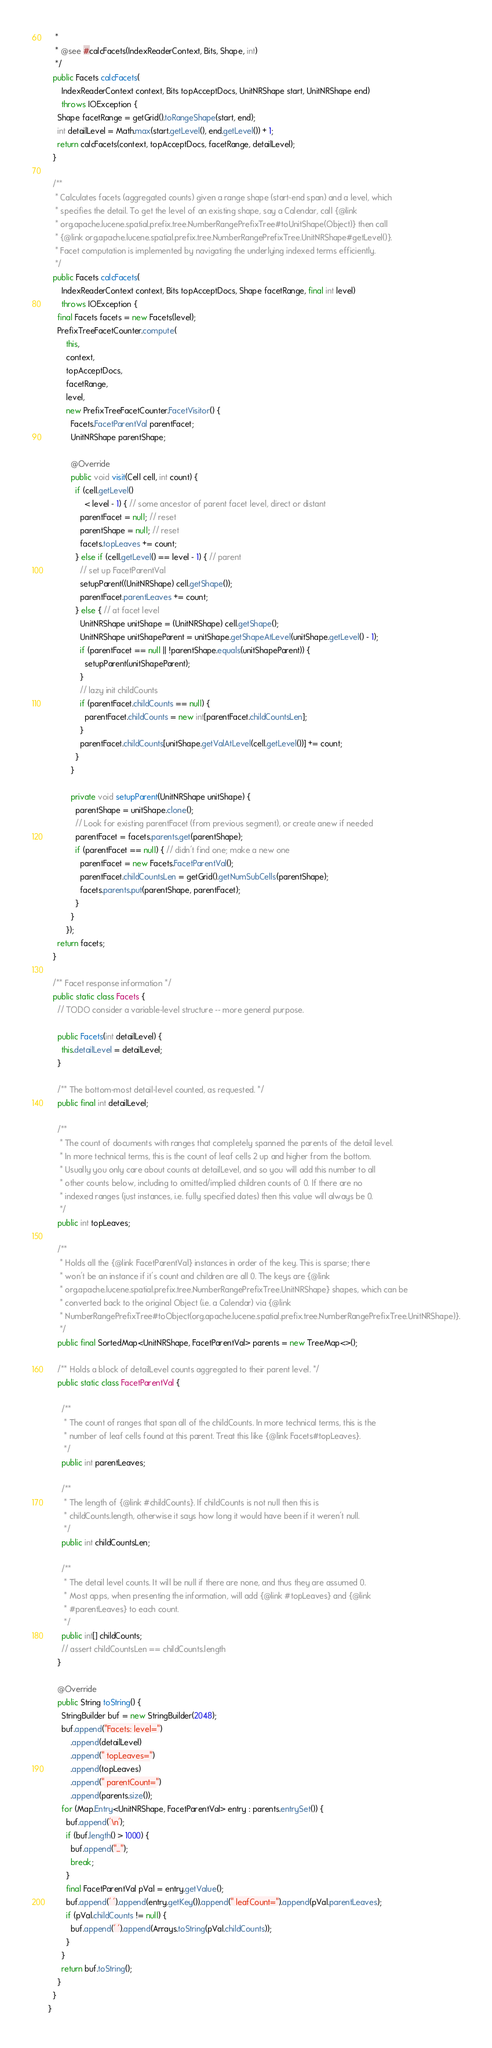Convert code to text. <code><loc_0><loc_0><loc_500><loc_500><_Java_>   *
   * @see #calcFacets(IndexReaderContext, Bits, Shape, int)
   */
  public Facets calcFacets(
      IndexReaderContext context, Bits topAcceptDocs, UnitNRShape start, UnitNRShape end)
      throws IOException {
    Shape facetRange = getGrid().toRangeShape(start, end);
    int detailLevel = Math.max(start.getLevel(), end.getLevel()) + 1;
    return calcFacets(context, topAcceptDocs, facetRange, detailLevel);
  }

  /**
   * Calculates facets (aggregated counts) given a range shape (start-end span) and a level, which
   * specifies the detail. To get the level of an existing shape, say a Calendar, call {@link
   * org.apache.lucene.spatial.prefix.tree.NumberRangePrefixTree#toUnitShape(Object)} then call
   * {@link org.apache.lucene.spatial.prefix.tree.NumberRangePrefixTree.UnitNRShape#getLevel()}.
   * Facet computation is implemented by navigating the underlying indexed terms efficiently.
   */
  public Facets calcFacets(
      IndexReaderContext context, Bits topAcceptDocs, Shape facetRange, final int level)
      throws IOException {
    final Facets facets = new Facets(level);
    PrefixTreeFacetCounter.compute(
        this,
        context,
        topAcceptDocs,
        facetRange,
        level,
        new PrefixTreeFacetCounter.FacetVisitor() {
          Facets.FacetParentVal parentFacet;
          UnitNRShape parentShape;

          @Override
          public void visit(Cell cell, int count) {
            if (cell.getLevel()
                < level - 1) { // some ancestor of parent facet level, direct or distant
              parentFacet = null; // reset
              parentShape = null; // reset
              facets.topLeaves += count;
            } else if (cell.getLevel() == level - 1) { // parent
              // set up FacetParentVal
              setupParent((UnitNRShape) cell.getShape());
              parentFacet.parentLeaves += count;
            } else { // at facet level
              UnitNRShape unitShape = (UnitNRShape) cell.getShape();
              UnitNRShape unitShapeParent = unitShape.getShapeAtLevel(unitShape.getLevel() - 1);
              if (parentFacet == null || !parentShape.equals(unitShapeParent)) {
                setupParent(unitShapeParent);
              }
              // lazy init childCounts
              if (parentFacet.childCounts == null) {
                parentFacet.childCounts = new int[parentFacet.childCountsLen];
              }
              parentFacet.childCounts[unitShape.getValAtLevel(cell.getLevel())] += count;
            }
          }

          private void setupParent(UnitNRShape unitShape) {
            parentShape = unitShape.clone();
            // Look for existing parentFacet (from previous segment), or create anew if needed
            parentFacet = facets.parents.get(parentShape);
            if (parentFacet == null) { // didn't find one; make a new one
              parentFacet = new Facets.FacetParentVal();
              parentFacet.childCountsLen = getGrid().getNumSubCells(parentShape);
              facets.parents.put(parentShape, parentFacet);
            }
          }
        });
    return facets;
  }

  /** Facet response information */
  public static class Facets {
    // TODO consider a variable-level structure -- more general purpose.

    public Facets(int detailLevel) {
      this.detailLevel = detailLevel;
    }

    /** The bottom-most detail-level counted, as requested. */
    public final int detailLevel;

    /**
     * The count of documents with ranges that completely spanned the parents of the detail level.
     * In more technical terms, this is the count of leaf cells 2 up and higher from the bottom.
     * Usually you only care about counts at detailLevel, and so you will add this number to all
     * other counts below, including to omitted/implied children counts of 0. If there are no
     * indexed ranges (just instances, i.e. fully specified dates) then this value will always be 0.
     */
    public int topLeaves;

    /**
     * Holds all the {@link FacetParentVal} instances in order of the key. This is sparse; there
     * won't be an instance if it's count and children are all 0. The keys are {@link
     * org.apache.lucene.spatial.prefix.tree.NumberRangePrefixTree.UnitNRShape} shapes, which can be
     * converted back to the original Object (i.e. a Calendar) via {@link
     * NumberRangePrefixTree#toObject(org.apache.lucene.spatial.prefix.tree.NumberRangePrefixTree.UnitNRShape)}.
     */
    public final SortedMap<UnitNRShape, FacetParentVal> parents = new TreeMap<>();

    /** Holds a block of detailLevel counts aggregated to their parent level. */
    public static class FacetParentVal {

      /**
       * The count of ranges that span all of the childCounts. In more technical terms, this is the
       * number of leaf cells found at this parent. Treat this like {@link Facets#topLeaves}.
       */
      public int parentLeaves;

      /**
       * The length of {@link #childCounts}. If childCounts is not null then this is
       * childCounts.length, otherwise it says how long it would have been if it weren't null.
       */
      public int childCountsLen;

      /**
       * The detail level counts. It will be null if there are none, and thus they are assumed 0.
       * Most apps, when presenting the information, will add {@link #topLeaves} and {@link
       * #parentLeaves} to each count.
       */
      public int[] childCounts;
      // assert childCountsLen == childCounts.length
    }

    @Override
    public String toString() {
      StringBuilder buf = new StringBuilder(2048);
      buf.append("Facets: level=")
          .append(detailLevel)
          .append(" topLeaves=")
          .append(topLeaves)
          .append(" parentCount=")
          .append(parents.size());
      for (Map.Entry<UnitNRShape, FacetParentVal> entry : parents.entrySet()) {
        buf.append('\n');
        if (buf.length() > 1000) {
          buf.append("...");
          break;
        }
        final FacetParentVal pVal = entry.getValue();
        buf.append(' ').append(entry.getKey()).append(" leafCount=").append(pVal.parentLeaves);
        if (pVal.childCounts != null) {
          buf.append(' ').append(Arrays.toString(pVal.childCounts));
        }
      }
      return buf.toString();
    }
  }
}
</code> 